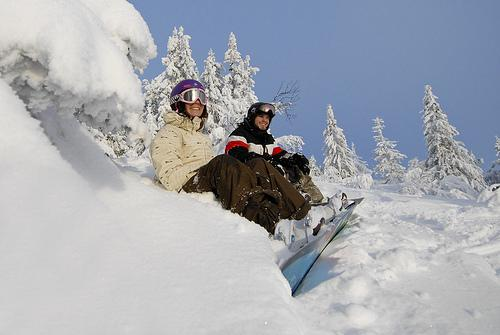Question: why are they there?
Choices:
A. To eat.
B. They are sitting down.
C. To play.
D. To perform.
Answer with the letter. Answer: B Question: who is on the mountain?
Choices:
A. Two people.
B. Skiiers.
C. Mountain climbers.
D. Shepherds.
Answer with the letter. Answer: A Question: how many people are there?
Choices:
A. 2.
B. 12.
C. 13.
D. 5.
Answer with the letter. Answer: A Question: when was the photo taken?
Choices:
A. Night time.
B. Noon.
C. Dawn.
D. During the day.
Answer with the letter. Answer: D Question: what is on the ground?
Choices:
A. Snow.
B. Grass.
C. Mud.
D. Concrete.
Answer with the letter. Answer: A 